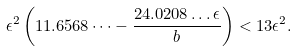Convert formula to latex. <formula><loc_0><loc_0><loc_500><loc_500>\epsilon ^ { 2 } \left ( 1 1 . 6 5 6 8 \dots - \frac { 2 4 . 0 2 0 8 \dots \epsilon } { b } \right ) < 1 3 \epsilon ^ { 2 } .</formula> 